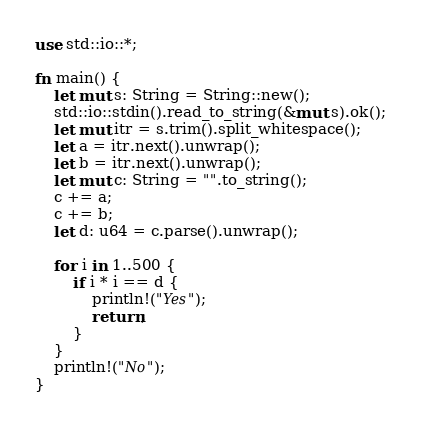<code> <loc_0><loc_0><loc_500><loc_500><_Rust_>use std::io::*;

fn main() {
    let mut s: String = String::new();
    std::io::stdin().read_to_string(&mut s).ok();
    let mut itr = s.trim().split_whitespace();
    let a = itr.next().unwrap();
    let b = itr.next().unwrap();
    let mut c: String = "".to_string();
    c += a;
    c += b;
    let d: u64 = c.parse().unwrap();

    for i in 1..500 {
        if i * i == d {
            println!("Yes");
            return;
        }
    }
    println!("No");
}
</code> 